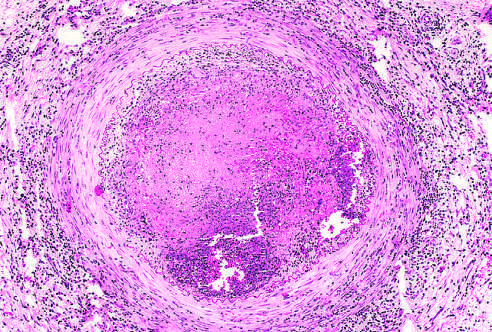re large, flat cells with small nuclei occluded by thrombus containing a sterile abscess?
Answer the question using a single word or phrase. No 